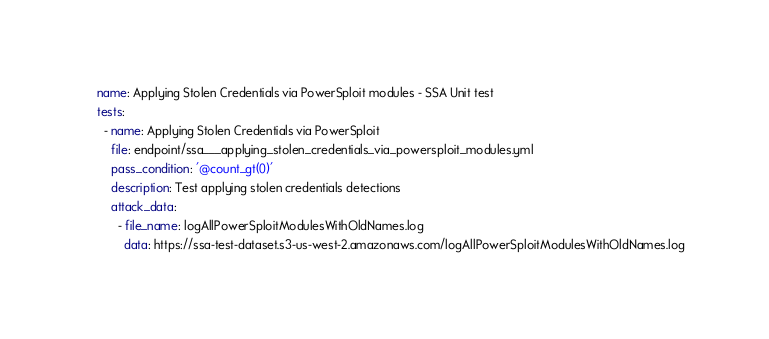<code> <loc_0><loc_0><loc_500><loc_500><_YAML_>name: Applying Stolen Credentials via PowerSploit modules - SSA Unit test
tests:
  - name: Applying Stolen Credentials via PowerSploit
    file: endpoint/ssa___applying_stolen_credentials_via_powersploit_modules.yml
    pass_condition: '@count_gt(0)'
    description: Test applying stolen credentials detections
    attack_data:
      - file_name: logAllPowerSploitModulesWithOldNames.log
        data: https://ssa-test-dataset.s3-us-west-2.amazonaws.com/logAllPowerSploitModulesWithOldNames.log

</code> 